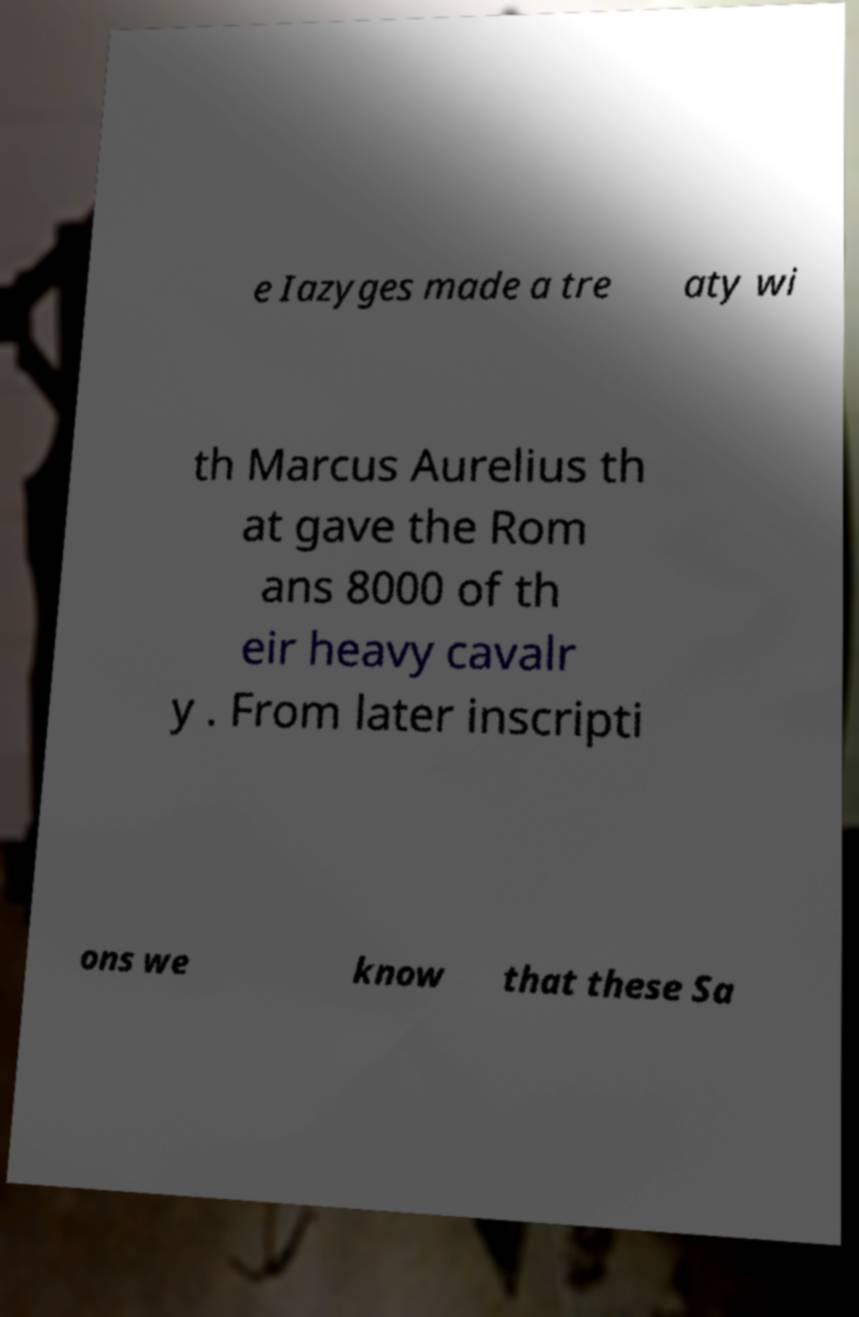There's text embedded in this image that I need extracted. Can you transcribe it verbatim? e Iazyges made a tre aty wi th Marcus Aurelius th at gave the Rom ans 8000 of th eir heavy cavalr y . From later inscripti ons we know that these Sa 